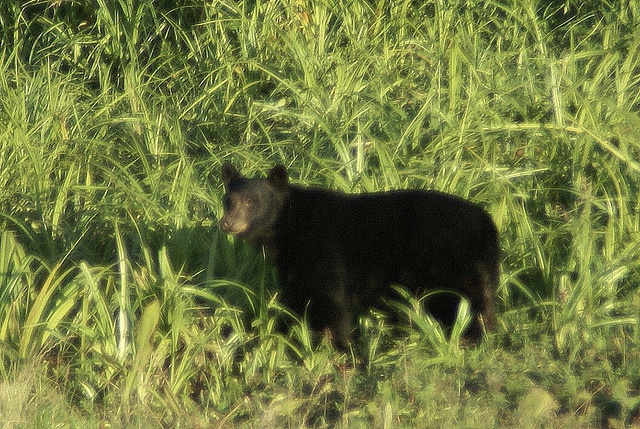Describe the objects in this image and their specific colors. I can see a bear in darkgreen, black, and gray tones in this image. 